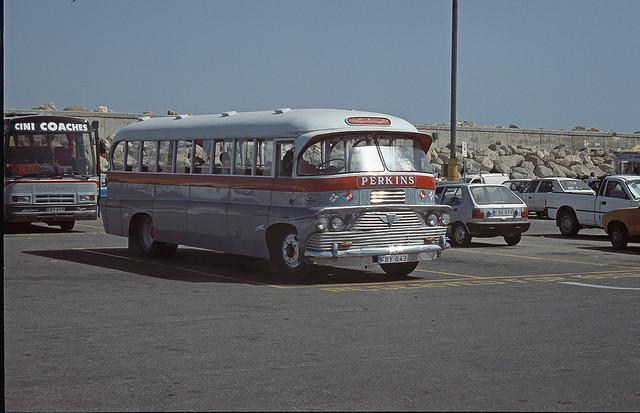What country's red white flag is on the Perkins bus? canada 